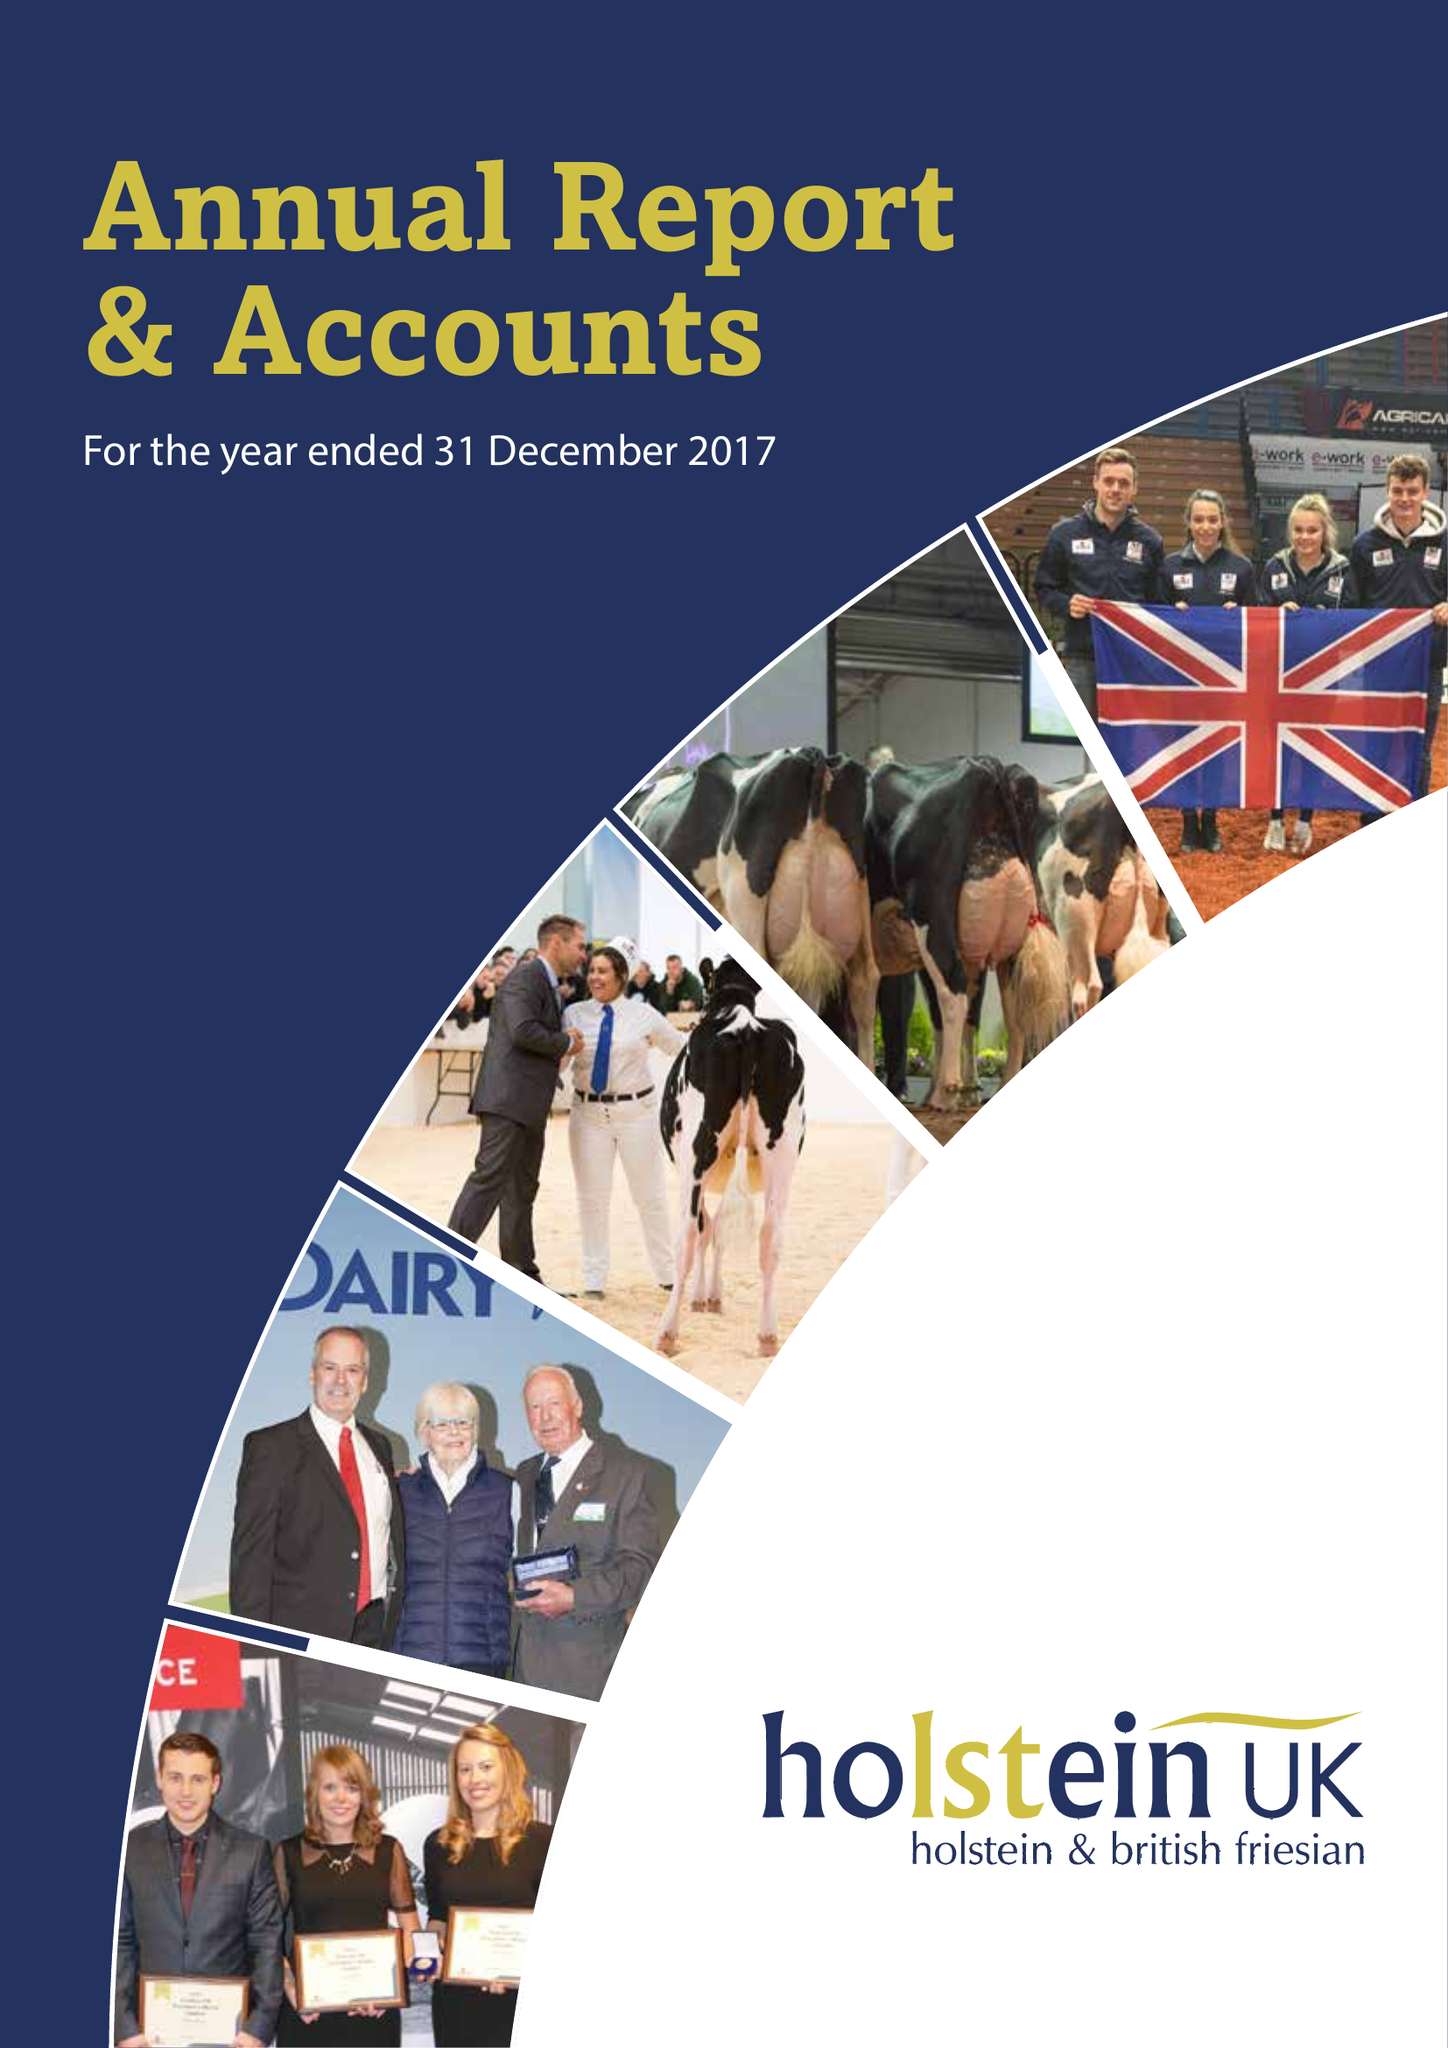What is the value for the address__street_line?
Answer the question using a single word or phrase. STAFFORD PARK 1 